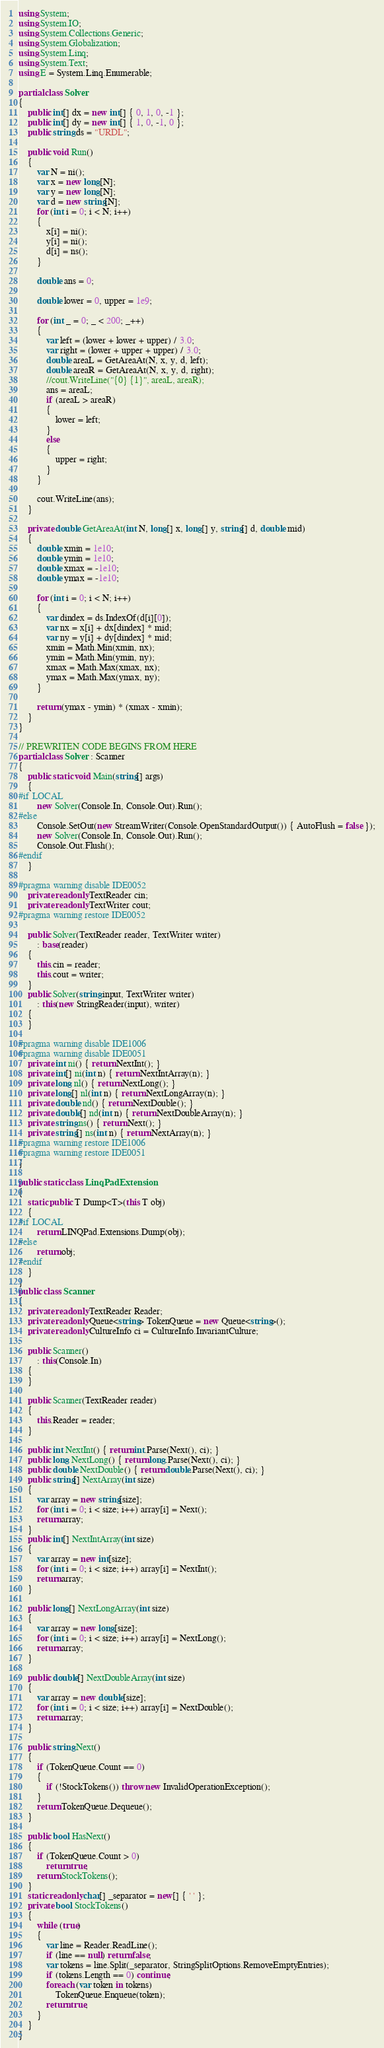Convert code to text. <code><loc_0><loc_0><loc_500><loc_500><_C#_>using System;
using System.IO;
using System.Collections.Generic;
using System.Globalization;
using System.Linq;
using System.Text;
using E = System.Linq.Enumerable;

partial class Solver
{
    public int[] dx = new int[] { 0, 1, 0, -1 };
    public int[] dy = new int[] { 1, 0, -1, 0 };
    public string ds = "URDL";

    public void Run()
    {
        var N = ni();
        var x = new long[N];
        var y = new long[N];
        var d = new string[N];
        for (int i = 0; i < N; i++)
        {
            x[i] = ni();
            y[i] = ni();
            d[i] = ns();
        }

        double ans = 0;

        double lower = 0, upper = 1e9;

        for (int _ = 0; _ < 200; _++)
        {
            var left = (lower + lower + upper) / 3.0;
            var right = (lower + upper + upper) / 3.0;
            double areaL = GetAreaAt(N, x, y, d, left);
            double areaR = GetAreaAt(N, x, y, d, right);
            //cout.WriteLine("{0} {1}", areaL, areaR);
            ans = areaL;
            if (areaL > areaR)
            {
                lower = left;
            }
            else
            {
                upper = right;
            }
        }

        cout.WriteLine(ans);
    }

    private double GetAreaAt(int N, long[] x, long[] y, string[] d, double mid)
    {
        double xmin = 1e10;
        double ymin = 1e10;
        double xmax = -1e10;
        double ymax = -1e10;

        for (int i = 0; i < N; i++)
        {
            var dindex = ds.IndexOf(d[i][0]);
            var nx = x[i] + dx[dindex] * mid;
            var ny = y[i] + dy[dindex] * mid;
            xmin = Math.Min(xmin, nx);
            ymin = Math.Min(ymin, ny);
            xmax = Math.Max(xmax, nx);
            ymax = Math.Max(ymax, ny);
        }

        return (ymax - ymin) * (xmax - xmin);
    }
}

// PREWRITEN CODE BEGINS FROM HERE
partial class Solver : Scanner
{
    public static void Main(string[] args)
    {
#if LOCAL
        new Solver(Console.In, Console.Out).Run();
#else
        Console.SetOut(new StreamWriter(Console.OpenStandardOutput()) { AutoFlush = false });
        new Solver(Console.In, Console.Out).Run();
        Console.Out.Flush();
#endif
    }

#pragma warning disable IDE0052
    private readonly TextReader cin;
    private readonly TextWriter cout;
#pragma warning restore IDE0052

    public Solver(TextReader reader, TextWriter writer)
        : base(reader)
    {
        this.cin = reader;
        this.cout = writer;
    }
    public Solver(string input, TextWriter writer)
        : this(new StringReader(input), writer)
    {
    }

#pragma warning disable IDE1006
#pragma warning disable IDE0051
    private int ni() { return NextInt(); }
    private int[] ni(int n) { return NextIntArray(n); }
    private long nl() { return NextLong(); }
    private long[] nl(int n) { return NextLongArray(n); }
    private double nd() { return NextDouble(); }
    private double[] nd(int n) { return NextDoubleArray(n); }
    private string ns() { return Next(); }
    private string[] ns(int n) { return NextArray(n); }
#pragma warning restore IDE1006
#pragma warning restore IDE0051
}

public static class LinqPadExtension
{
    static public T Dump<T>(this T obj)
    {
#if LOCAL
        return LINQPad.Extensions.Dump(obj);
#else
        return obj;
#endif
    }
}
public class Scanner
{
    private readonly TextReader Reader;
    private readonly Queue<string> TokenQueue = new Queue<string>();
    private readonly CultureInfo ci = CultureInfo.InvariantCulture;

    public Scanner()
        : this(Console.In)
    {
    }

    public Scanner(TextReader reader)
    {
        this.Reader = reader;
    }

    public int NextInt() { return int.Parse(Next(), ci); }
    public long NextLong() { return long.Parse(Next(), ci); }
    public double NextDouble() { return double.Parse(Next(), ci); }
    public string[] NextArray(int size)
    {
        var array = new string[size];
        for (int i = 0; i < size; i++) array[i] = Next();
        return array;
    }
    public int[] NextIntArray(int size)
    {
        var array = new int[size];
        for (int i = 0; i < size; i++) array[i] = NextInt();
        return array;
    }

    public long[] NextLongArray(int size)
    {
        var array = new long[size];
        for (int i = 0; i < size; i++) array[i] = NextLong();
        return array;
    }

    public double[] NextDoubleArray(int size)
    {
        var array = new double[size];
        for (int i = 0; i < size; i++) array[i] = NextDouble();
        return array;
    }

    public string Next()
    {
        if (TokenQueue.Count == 0)
        {
            if (!StockTokens()) throw new InvalidOperationException();
        }
        return TokenQueue.Dequeue();
    }

    public bool HasNext()
    {
        if (TokenQueue.Count > 0)
            return true;
        return StockTokens();
    }
    static readonly char[] _separator = new[] { ' ' };
    private bool StockTokens()
    {
        while (true)
        {
            var line = Reader.ReadLine();
            if (line == null) return false;
            var tokens = line.Split(_separator, StringSplitOptions.RemoveEmptyEntries);
            if (tokens.Length == 0) continue;
            foreach (var token in tokens)
                TokenQueue.Enqueue(token);
            return true;
        }
    }
}
</code> 